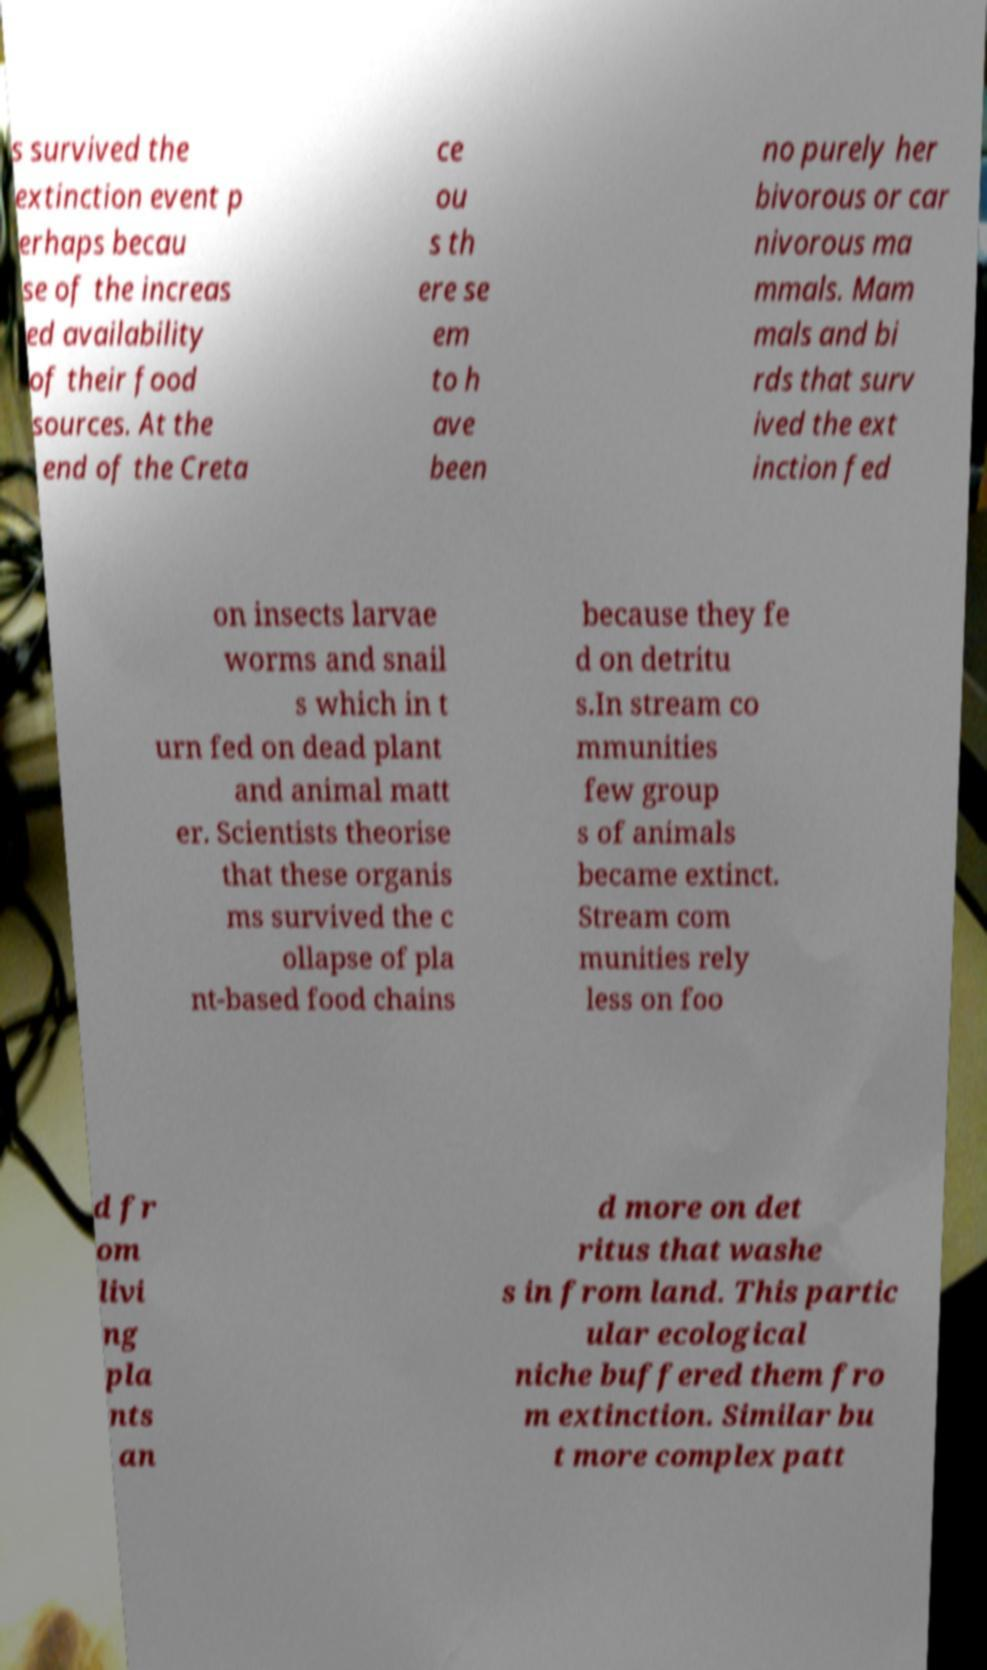Could you assist in decoding the text presented in this image and type it out clearly? s survived the extinction event p erhaps becau se of the increas ed availability of their food sources. At the end of the Creta ce ou s th ere se em to h ave been no purely her bivorous or car nivorous ma mmals. Mam mals and bi rds that surv ived the ext inction fed on insects larvae worms and snail s which in t urn fed on dead plant and animal matt er. Scientists theorise that these organis ms survived the c ollapse of pla nt-based food chains because they fe d on detritu s.In stream co mmunities few group s of animals became extinct. Stream com munities rely less on foo d fr om livi ng pla nts an d more on det ritus that washe s in from land. This partic ular ecological niche buffered them fro m extinction. Similar bu t more complex patt 